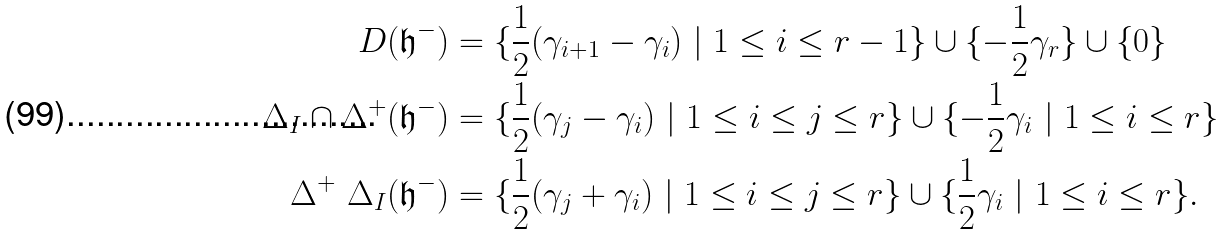<formula> <loc_0><loc_0><loc_500><loc_500>D ( \mathfrak { h } ^ { - } ) & = \{ \frac { 1 } { 2 } ( \gamma _ { i + 1 } - \gamma _ { i } ) \ | \ 1 \leq i \leq r - 1 \} \cup \{ - \frac { 1 } { 2 } \gamma _ { r } \} \cup \{ 0 \} \\ \Delta _ { I } \cap \Delta ^ { + } ( \mathfrak { h } ^ { - } ) & = \{ \frac { 1 } { 2 } ( \gamma _ { j } - \gamma _ { i } ) \ | \ 1 \leq i \leq j \leq r \} \cup \{ - \frac { 1 } { 2 } \gamma _ { i } \ | \ 1 \leq i \leq r \} \\ \Delta ^ { + } \ \Delta _ { I } ( \mathfrak { h } ^ { - } ) & = \{ \frac { 1 } { 2 } ( \gamma _ { j } + \gamma _ { i } ) \ | \ 1 \leq i \leq j \leq r \} \cup \{ \frac { 1 } { 2 } \gamma _ { i } \ | \ 1 \leq i \leq r \} . \\</formula> 